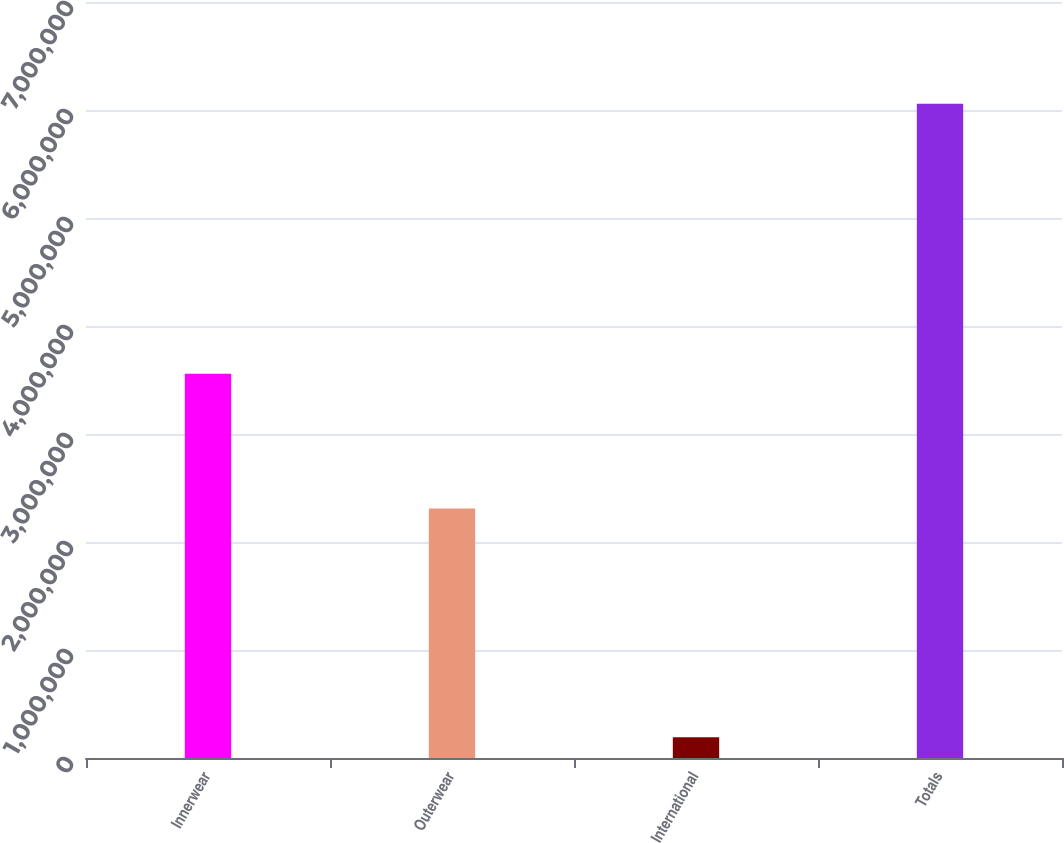Convert chart. <chart><loc_0><loc_0><loc_500><loc_500><bar_chart><fcel>Innerwear<fcel>Outerwear<fcel>International<fcel>Totals<nl><fcel>3.55718e+06<fcel>2.30915e+06<fcel>191793<fcel>6.05813e+06<nl></chart> 